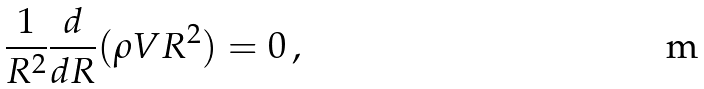<formula> <loc_0><loc_0><loc_500><loc_500>\frac { 1 } { R ^ { 2 } } \frac { d } { d R } ( \rho V R ^ { 2 } ) = 0 \, ,</formula> 